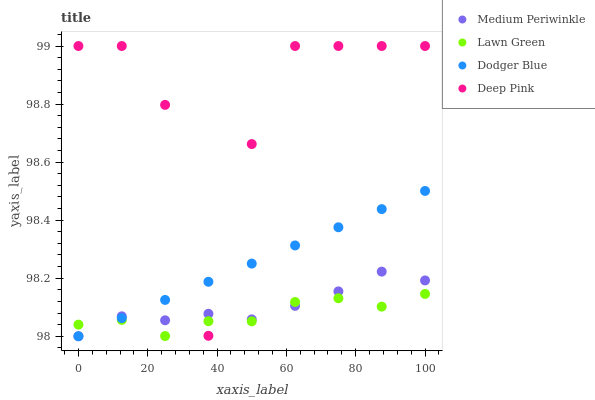Does Lawn Green have the minimum area under the curve?
Answer yes or no. Yes. Does Deep Pink have the maximum area under the curve?
Answer yes or no. Yes. Does Medium Periwinkle have the minimum area under the curve?
Answer yes or no. No. Does Medium Periwinkle have the maximum area under the curve?
Answer yes or no. No. Is Dodger Blue the smoothest?
Answer yes or no. Yes. Is Deep Pink the roughest?
Answer yes or no. Yes. Is Medium Periwinkle the smoothest?
Answer yes or no. No. Is Medium Periwinkle the roughest?
Answer yes or no. No. Does Medium Periwinkle have the lowest value?
Answer yes or no. Yes. Does Deep Pink have the lowest value?
Answer yes or no. No. Does Deep Pink have the highest value?
Answer yes or no. Yes. Does Medium Periwinkle have the highest value?
Answer yes or no. No. Does Deep Pink intersect Dodger Blue?
Answer yes or no. Yes. Is Deep Pink less than Dodger Blue?
Answer yes or no. No. Is Deep Pink greater than Dodger Blue?
Answer yes or no. No. 